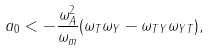<formula> <loc_0><loc_0><loc_500><loc_500>a _ { 0 } < - \frac { \omega _ { A } ^ { 2 } } { \omega _ { m } } ( \omega _ { T } \omega _ { Y } - \omega _ { T Y } \omega _ { Y T } ) ,</formula> 